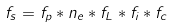<formula> <loc_0><loc_0><loc_500><loc_500>f _ { s } = f _ { p } * n _ { e } * f _ { L } * f _ { i } * f _ { c }</formula> 